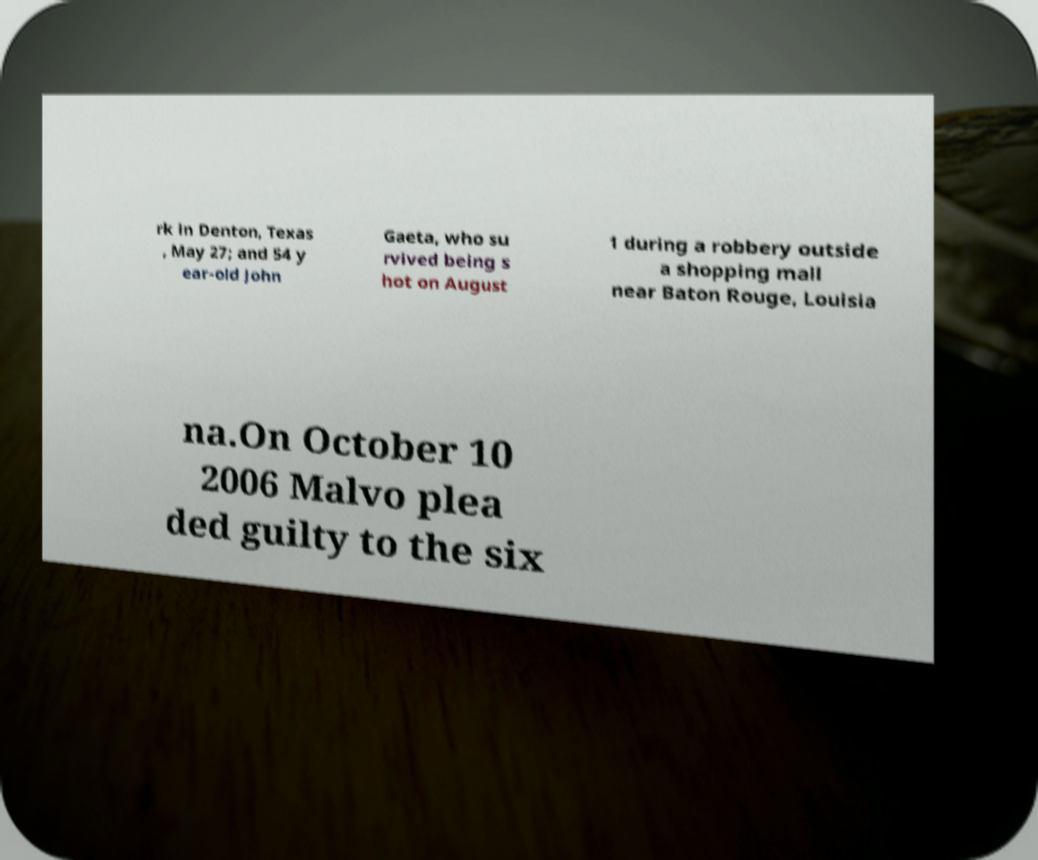Can you read and provide the text displayed in the image?This photo seems to have some interesting text. Can you extract and type it out for me? rk in Denton, Texas , May 27; and 54 y ear-old John Gaeta, who su rvived being s hot on August 1 during a robbery outside a shopping mall near Baton Rouge, Louisia na.On October 10 2006 Malvo plea ded guilty to the six 